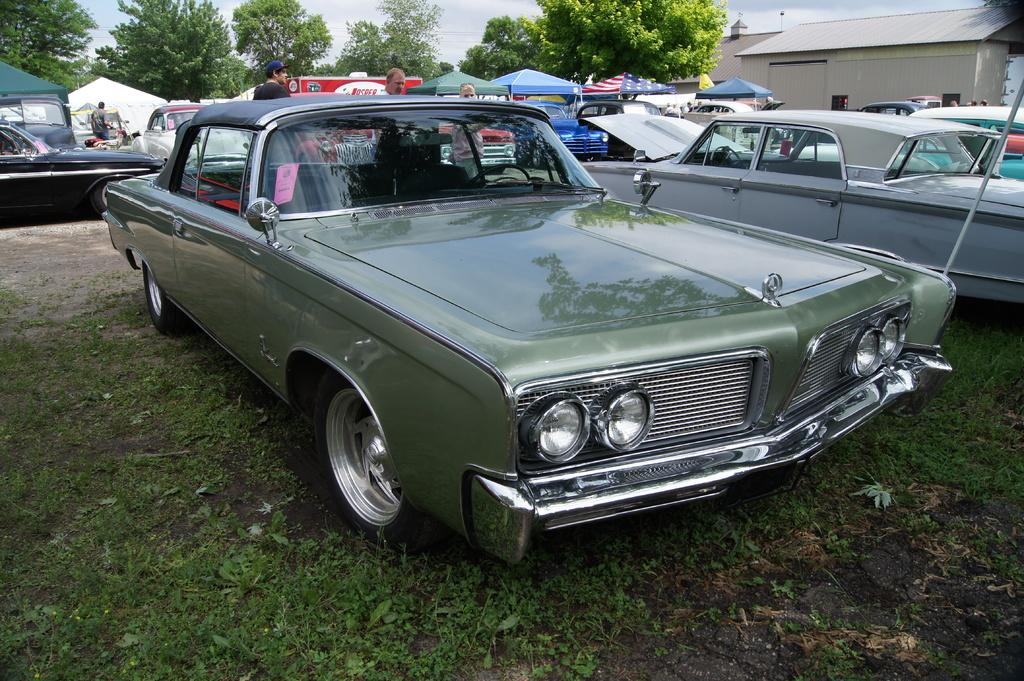What is located on the ground in the image? There are vehicles parked on the ground, tents, and people in the image. What type of structures can be seen at the top of the image? Trees, the sky, and a house are visible at the top of the image. What type of writing can be seen on the tents in the image? There is no writing visible on the tents in the image. What type of star is visible in the sky in the image? There is no star visible in the sky in the image; only the sky and a house are visible at the top of the image. 